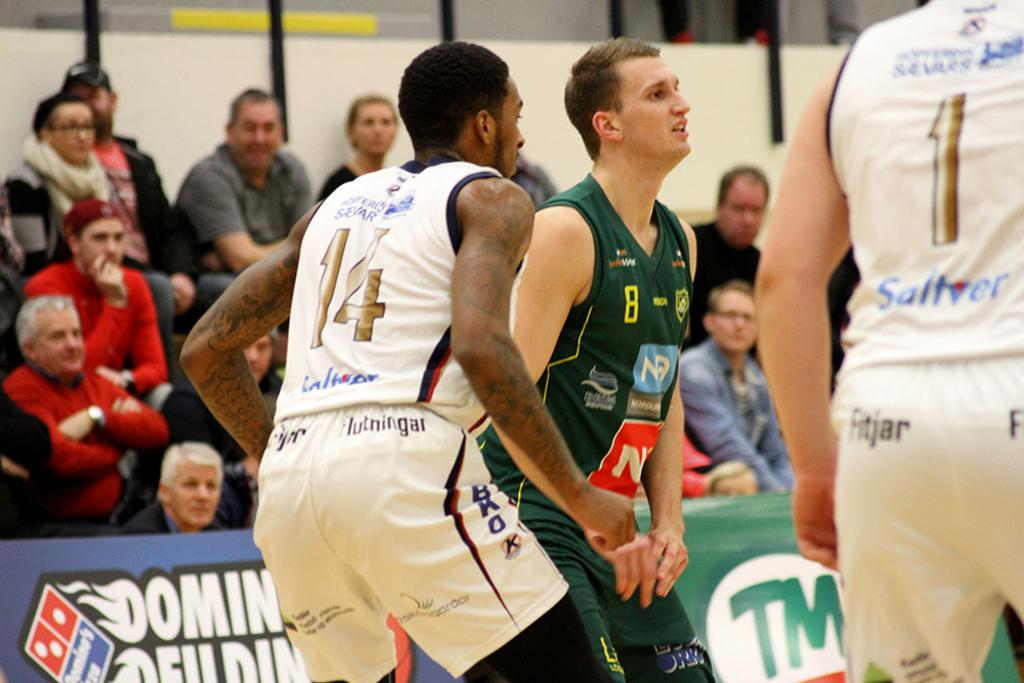Provide a one-sentence caption for the provided image. A few basketball players playing and one wears 14. 